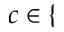Convert formula to latex. <formula><loc_0><loc_0><loc_500><loc_500>c \in \{</formula> 